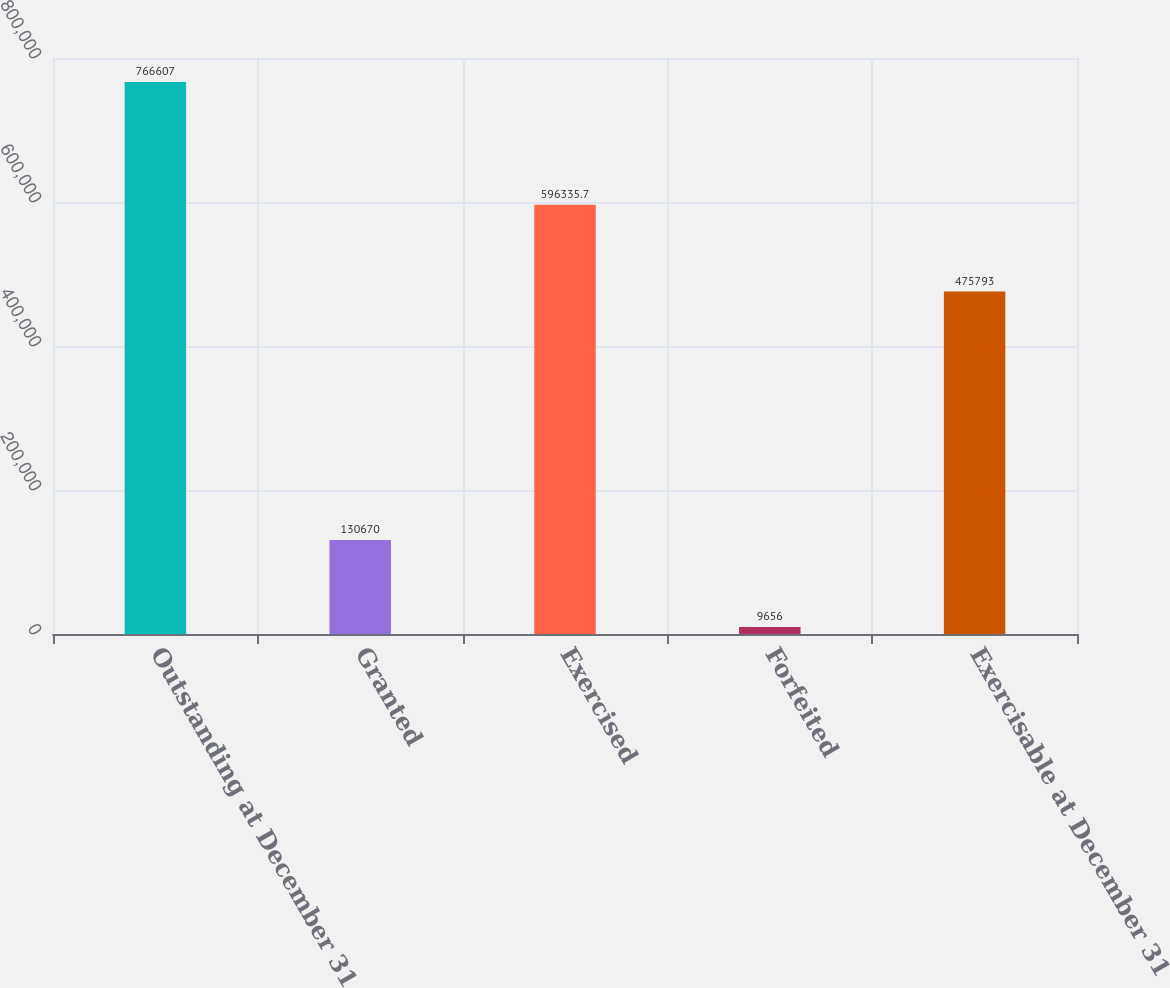Convert chart. <chart><loc_0><loc_0><loc_500><loc_500><bar_chart><fcel>Outstanding at December 31<fcel>Granted<fcel>Exercised<fcel>Forfeited<fcel>Exercisable at December 31<nl><fcel>766607<fcel>130670<fcel>596336<fcel>9656<fcel>475793<nl></chart> 